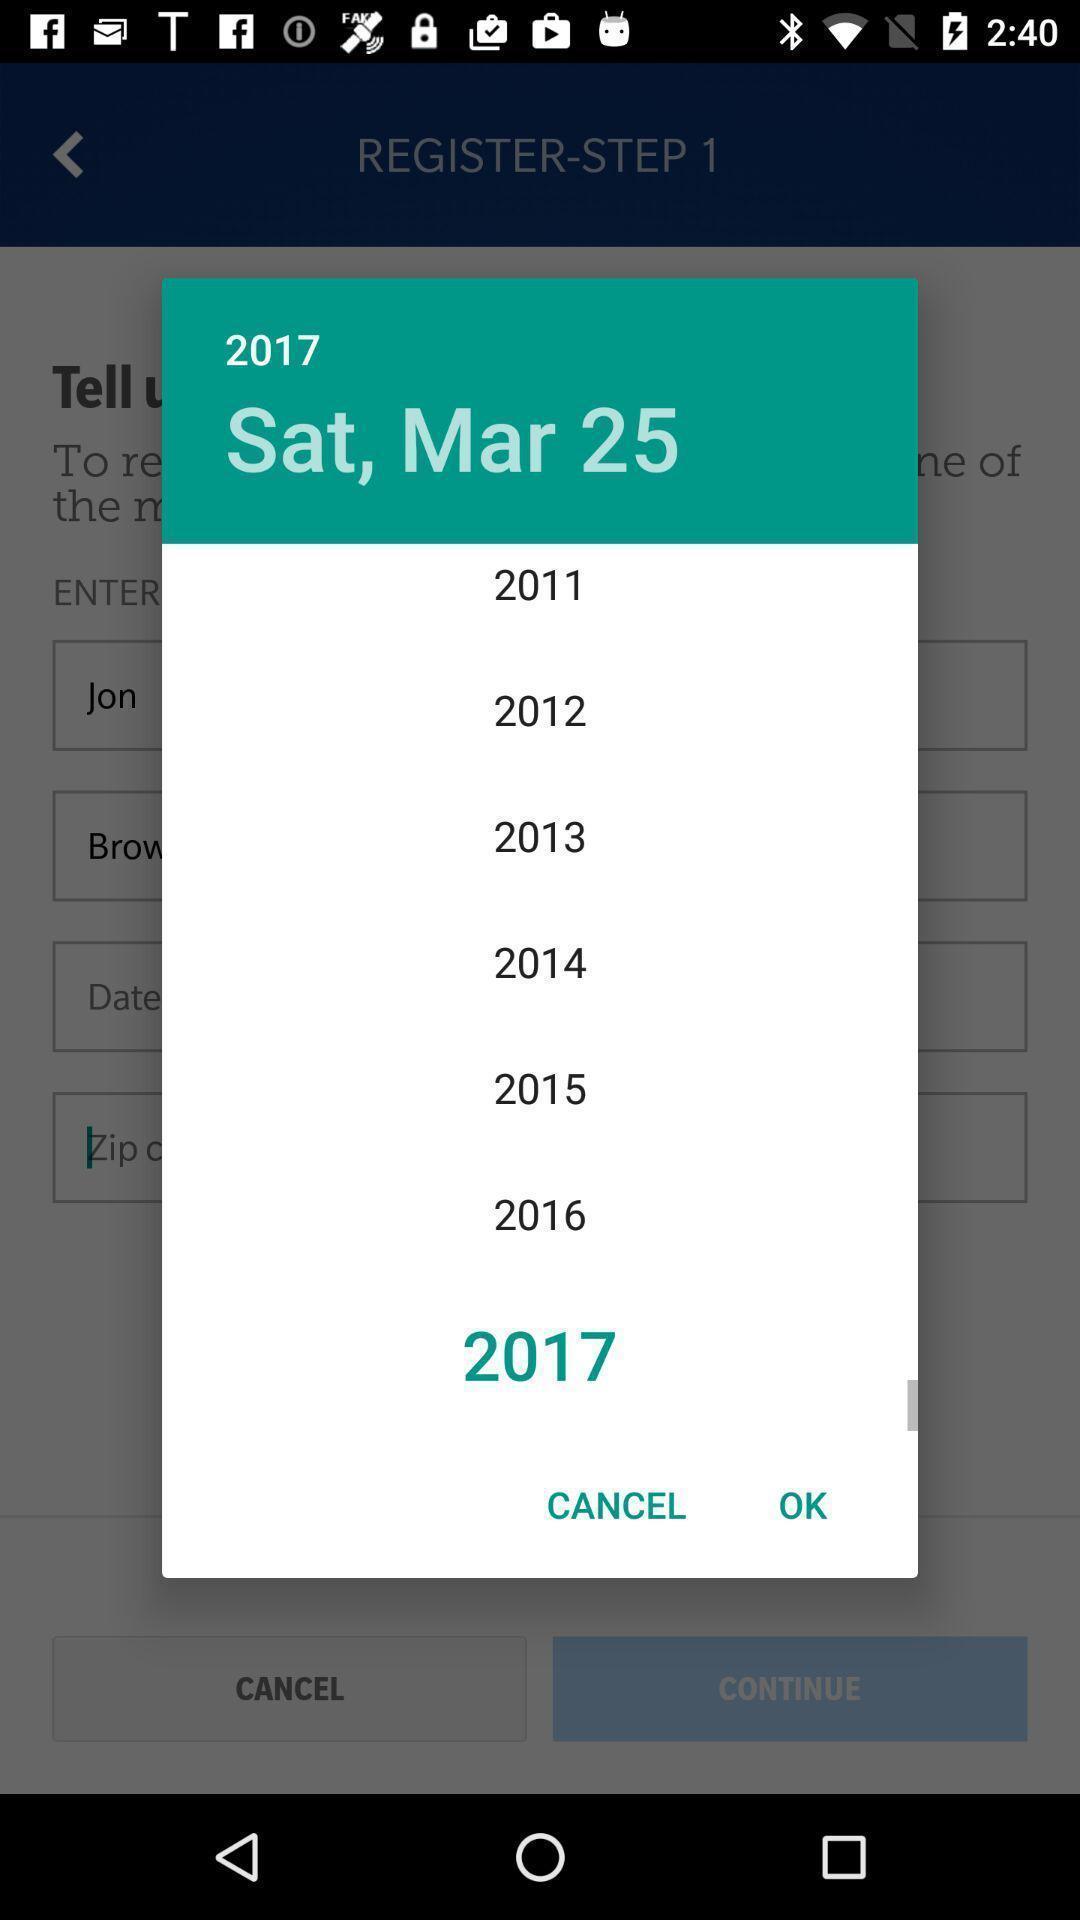What can you discern from this picture? Pop-up shows year details. 